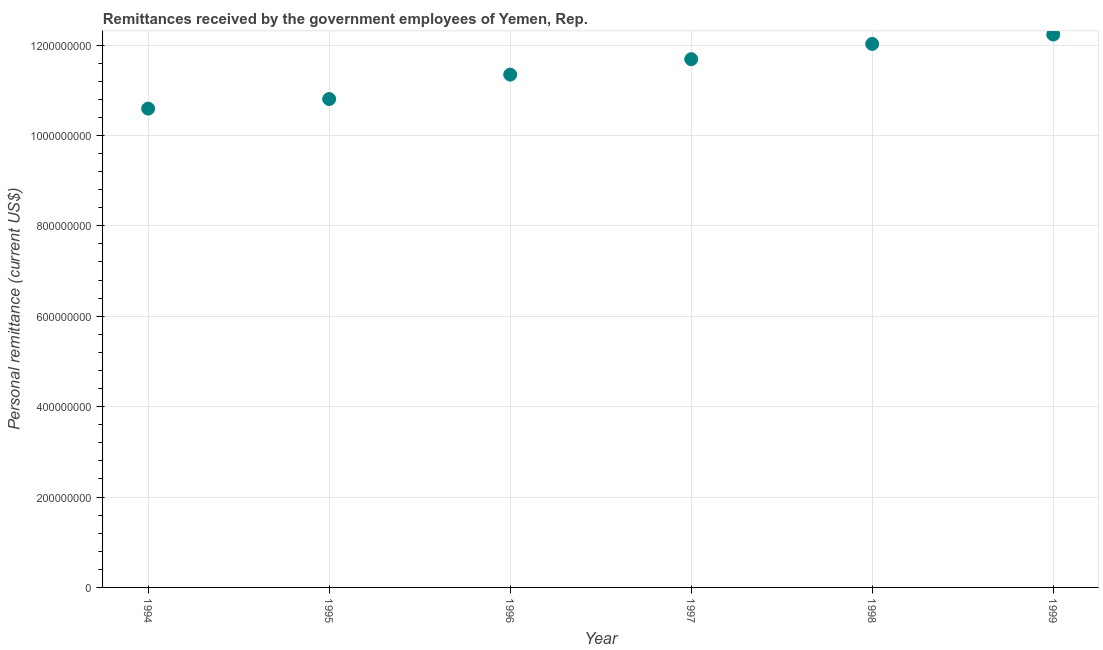What is the personal remittances in 1998?
Make the answer very short. 1.20e+09. Across all years, what is the maximum personal remittances?
Offer a terse response. 1.22e+09. Across all years, what is the minimum personal remittances?
Provide a short and direct response. 1.06e+09. In which year was the personal remittances maximum?
Make the answer very short. 1999. What is the sum of the personal remittances?
Offer a very short reply. 6.87e+09. What is the difference between the personal remittances in 1994 and 1999?
Offer a terse response. -1.64e+08. What is the average personal remittances per year?
Your answer should be very brief. 1.14e+09. What is the median personal remittances?
Offer a terse response. 1.15e+09. In how many years, is the personal remittances greater than 920000000 US$?
Make the answer very short. 6. Do a majority of the years between 1997 and 1999 (inclusive) have personal remittances greater than 640000000 US$?
Offer a terse response. Yes. What is the ratio of the personal remittances in 1995 to that in 1999?
Offer a terse response. 0.88. What is the difference between the highest and the second highest personal remittances?
Make the answer very short. 2.08e+07. Is the sum of the personal remittances in 1995 and 1998 greater than the maximum personal remittances across all years?
Offer a terse response. Yes. What is the difference between the highest and the lowest personal remittances?
Give a very brief answer. 1.64e+08. In how many years, is the personal remittances greater than the average personal remittances taken over all years?
Provide a succinct answer. 3. How many dotlines are there?
Provide a short and direct response. 1. How many years are there in the graph?
Offer a terse response. 6. Are the values on the major ticks of Y-axis written in scientific E-notation?
Give a very brief answer. No. Does the graph contain any zero values?
Offer a terse response. No. What is the title of the graph?
Make the answer very short. Remittances received by the government employees of Yemen, Rep. What is the label or title of the X-axis?
Provide a succinct answer. Year. What is the label or title of the Y-axis?
Ensure brevity in your answer.  Personal remittance (current US$). What is the Personal remittance (current US$) in 1994?
Provide a short and direct response. 1.06e+09. What is the Personal remittance (current US$) in 1995?
Give a very brief answer. 1.08e+09. What is the Personal remittance (current US$) in 1996?
Your answer should be compact. 1.13e+09. What is the Personal remittance (current US$) in 1997?
Offer a very short reply. 1.17e+09. What is the Personal remittance (current US$) in 1998?
Give a very brief answer. 1.20e+09. What is the Personal remittance (current US$) in 1999?
Offer a terse response. 1.22e+09. What is the difference between the Personal remittance (current US$) in 1994 and 1995?
Provide a short and direct response. -2.12e+07. What is the difference between the Personal remittance (current US$) in 1994 and 1996?
Your response must be concise. -7.52e+07. What is the difference between the Personal remittance (current US$) in 1994 and 1997?
Your answer should be compact. -1.09e+08. What is the difference between the Personal remittance (current US$) in 1994 and 1998?
Ensure brevity in your answer.  -1.43e+08. What is the difference between the Personal remittance (current US$) in 1994 and 1999?
Keep it short and to the point. -1.64e+08. What is the difference between the Personal remittance (current US$) in 1995 and 1996?
Provide a succinct answer. -5.40e+07. What is the difference between the Personal remittance (current US$) in 1995 and 1997?
Provide a short and direct response. -8.81e+07. What is the difference between the Personal remittance (current US$) in 1995 and 1998?
Ensure brevity in your answer.  -1.22e+08. What is the difference between the Personal remittance (current US$) in 1995 and 1999?
Provide a succinct answer. -1.43e+08. What is the difference between the Personal remittance (current US$) in 1996 and 1997?
Give a very brief answer. -3.41e+07. What is the difference between the Personal remittance (current US$) in 1996 and 1998?
Give a very brief answer. -6.79e+07. What is the difference between the Personal remittance (current US$) in 1996 and 1999?
Offer a very short reply. -8.87e+07. What is the difference between the Personal remittance (current US$) in 1997 and 1998?
Provide a short and direct response. -3.38e+07. What is the difference between the Personal remittance (current US$) in 1997 and 1999?
Offer a very short reply. -5.46e+07. What is the difference between the Personal remittance (current US$) in 1998 and 1999?
Make the answer very short. -2.08e+07. What is the ratio of the Personal remittance (current US$) in 1994 to that in 1995?
Make the answer very short. 0.98. What is the ratio of the Personal remittance (current US$) in 1994 to that in 1996?
Make the answer very short. 0.93. What is the ratio of the Personal remittance (current US$) in 1994 to that in 1997?
Ensure brevity in your answer.  0.91. What is the ratio of the Personal remittance (current US$) in 1994 to that in 1998?
Keep it short and to the point. 0.88. What is the ratio of the Personal remittance (current US$) in 1994 to that in 1999?
Provide a short and direct response. 0.87. What is the ratio of the Personal remittance (current US$) in 1995 to that in 1997?
Make the answer very short. 0.93. What is the ratio of the Personal remittance (current US$) in 1995 to that in 1998?
Offer a very short reply. 0.9. What is the ratio of the Personal remittance (current US$) in 1995 to that in 1999?
Provide a succinct answer. 0.88. What is the ratio of the Personal remittance (current US$) in 1996 to that in 1997?
Offer a terse response. 0.97. What is the ratio of the Personal remittance (current US$) in 1996 to that in 1998?
Your answer should be compact. 0.94. What is the ratio of the Personal remittance (current US$) in 1996 to that in 1999?
Your answer should be compact. 0.93. What is the ratio of the Personal remittance (current US$) in 1997 to that in 1999?
Provide a short and direct response. 0.95. 